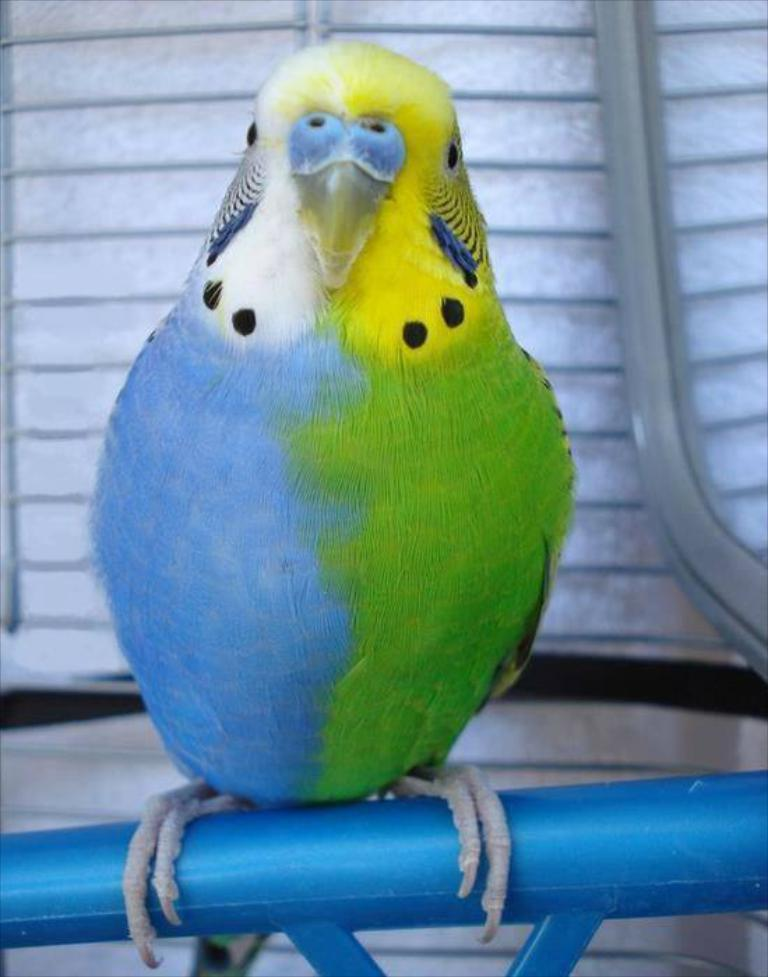What type of animal is in the image? There is a colorful parrot in the image. What is the parrot standing on? The parrot is standing on a blue road. How many sisters are present in the image? There are no sisters mentioned or depicted in the image. What type of lace can be seen on the parrot's wings? The parrot's wings do not have any lace; they are covered in feathers. 